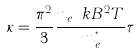Convert formula to latex. <formula><loc_0><loc_0><loc_500><loc_500>\kappa = \frac { \pi ^ { 2 } } { 3 } \frac { n _ { e } \ k B ^ { 2 } T } { m _ { e } ^ { ^ { * } } } \tau</formula> 